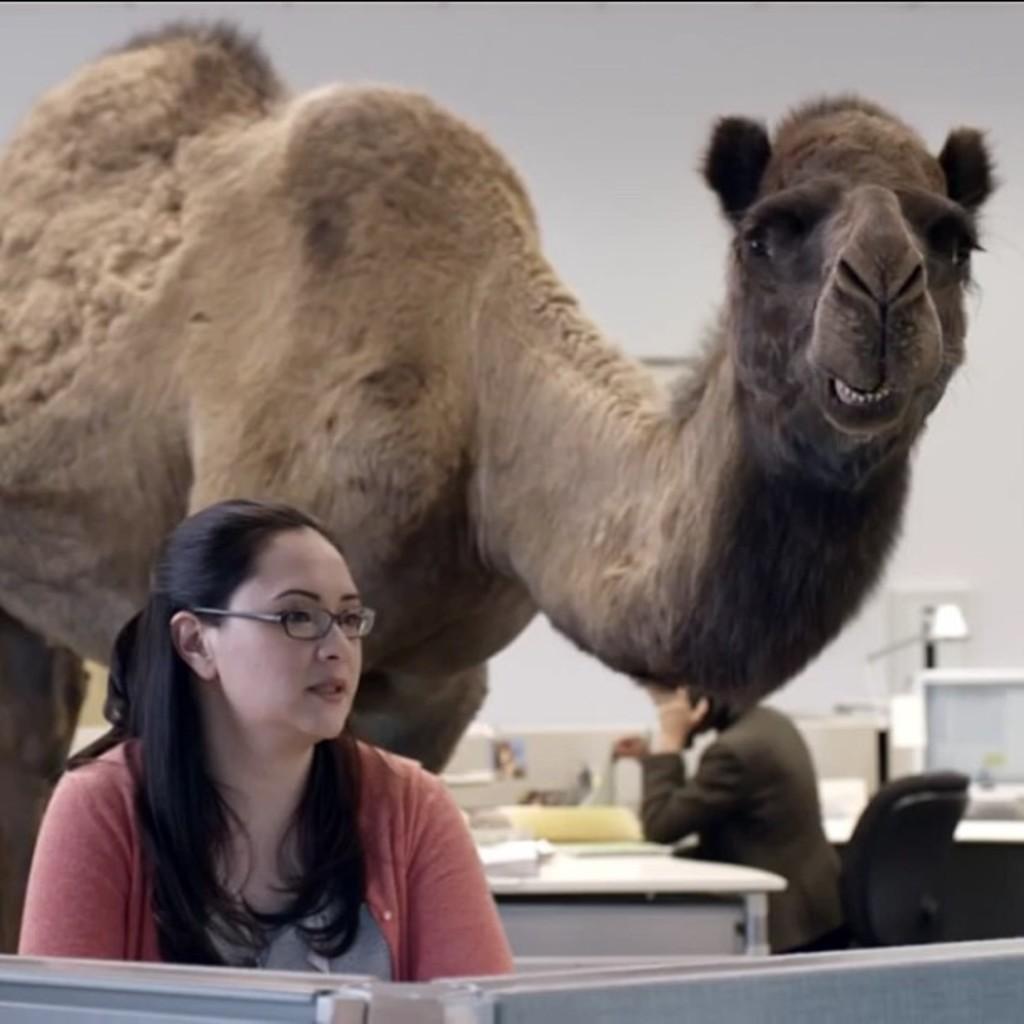Could you give a brief overview of what you see in this image? In this image we can see a woman and there is a person sitting on the chair. In the background we can see a camel, table, wall, and other objects. 